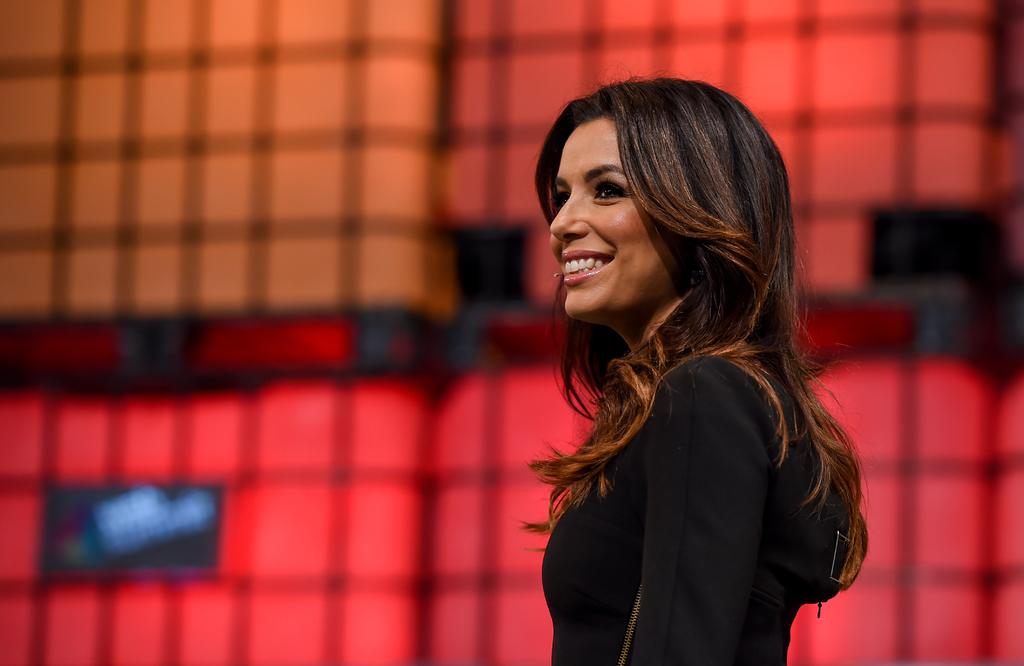Who is present in the image? There is a woman in the image. What is the woman's facial expression? The woman is smiling. Can you describe the background of the image? The background of the image is blurred. What can be seen in the background of the image? Objects are visible in the background of the image. What type of jar is being used to order food in the image? There is no jar or food ordering present in the image; it features a woman smiling with a blurred background. 